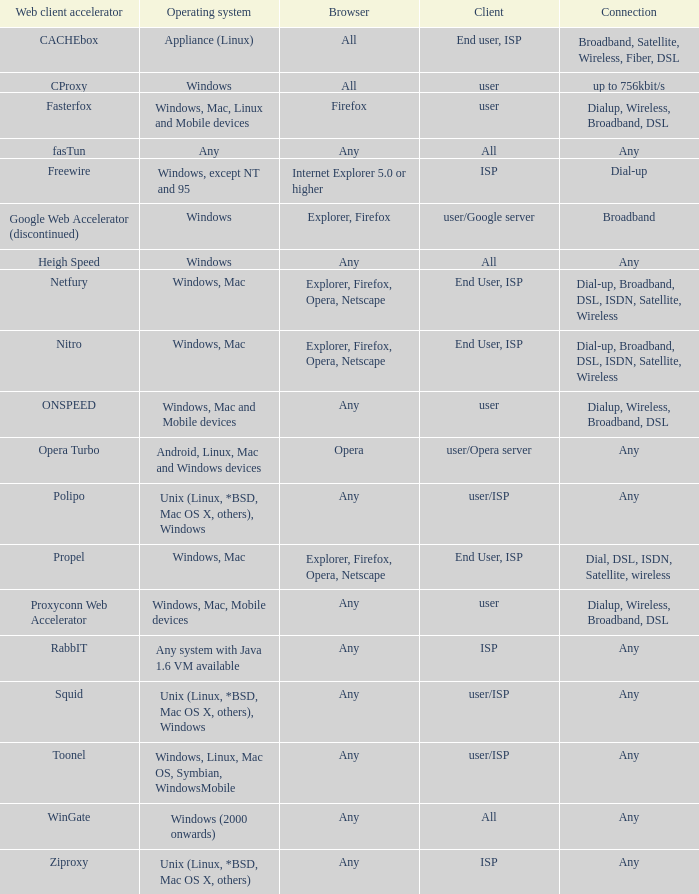What is the link for the proxyconn web accelerator web client accelerator? Dialup, Wireless, Broadband, DSL. 